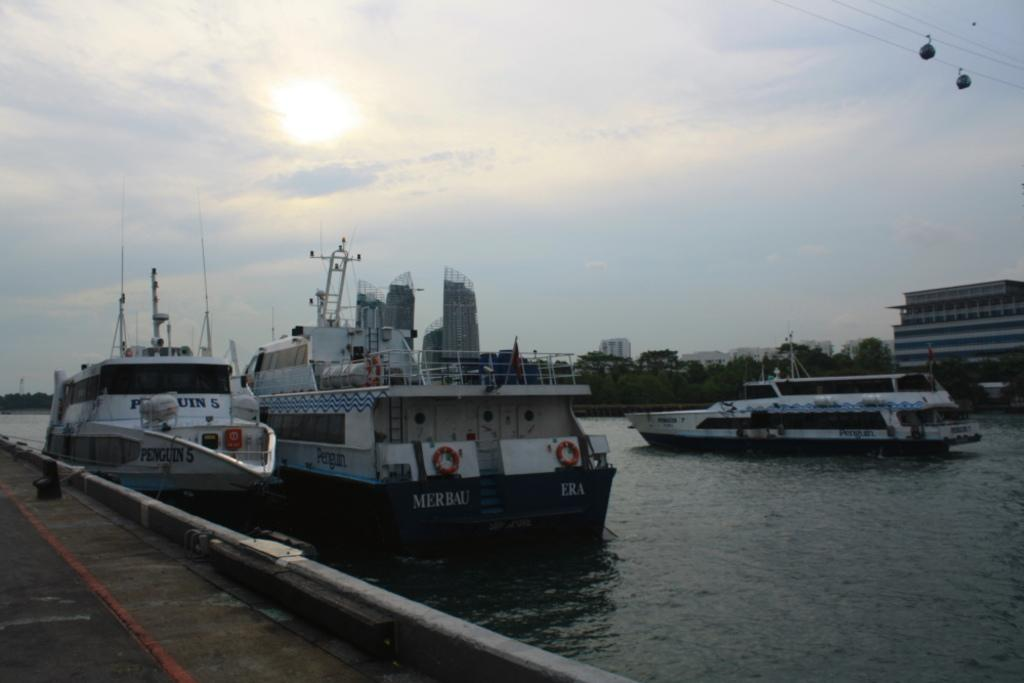What is located on the left side of the image? There is a road on the left side of the image. What can be seen on the water in the image? There are ships on the water in the image. What is visible in the background of the image? There are buildings, trees, and clouds in the sky in the background of the image. What is present on the right side at the top of the image? There are two cable cars on the right side at the top of the image. What type of industry can be seen in the wilderness area of the image? There is no wilderness area or industry present in the image. What board game is being played by the people in the image? There are no people or board games present in the image. 